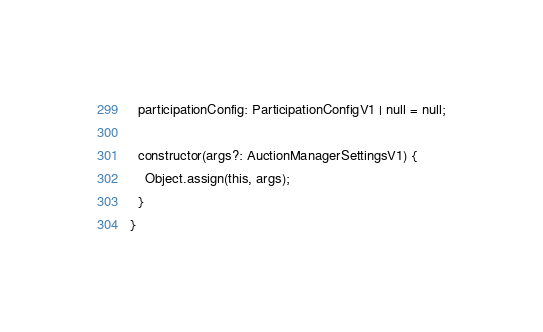<code> <loc_0><loc_0><loc_500><loc_500><_TypeScript_>  participationConfig: ParticipationConfigV1 | null = null;

  constructor(args?: AuctionManagerSettingsV1) {
    Object.assign(this, args);
  }
}
</code> 